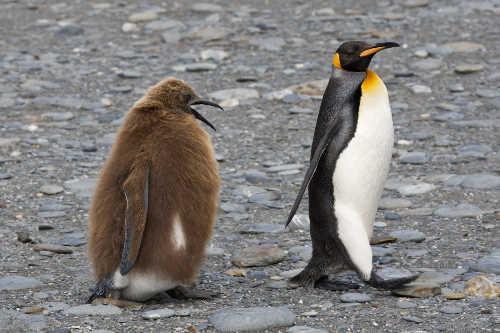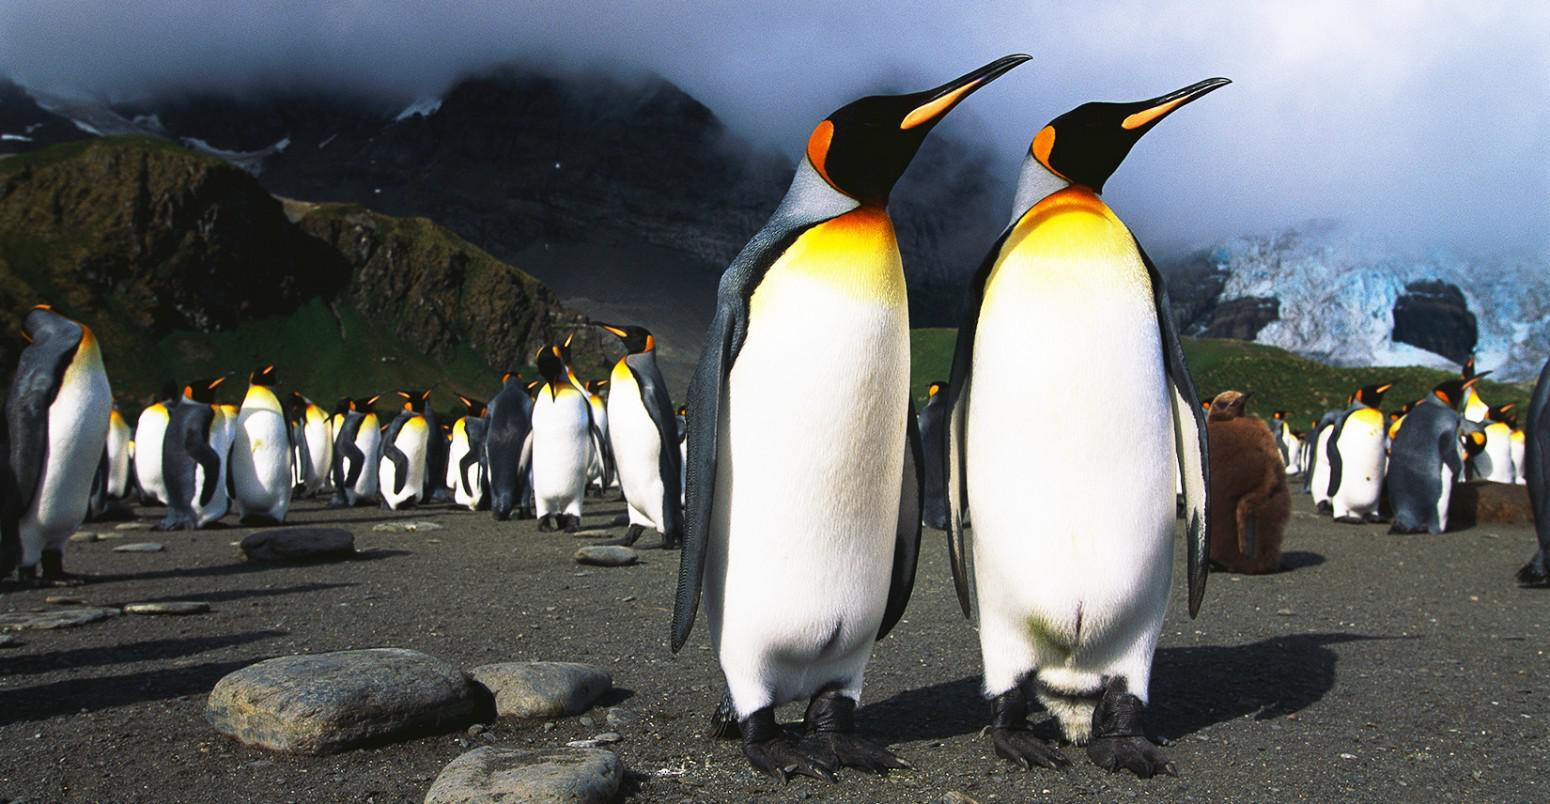The first image is the image on the left, the second image is the image on the right. Examine the images to the left and right. Is the description "An image contains no more than two penguins, and includes a penguin with some fuzzy non-sleek feathers." accurate? Answer yes or no. Yes. The first image is the image on the left, the second image is the image on the right. For the images shown, is this caption "There are no more than two penguins in the image on the left." true? Answer yes or no. Yes. 